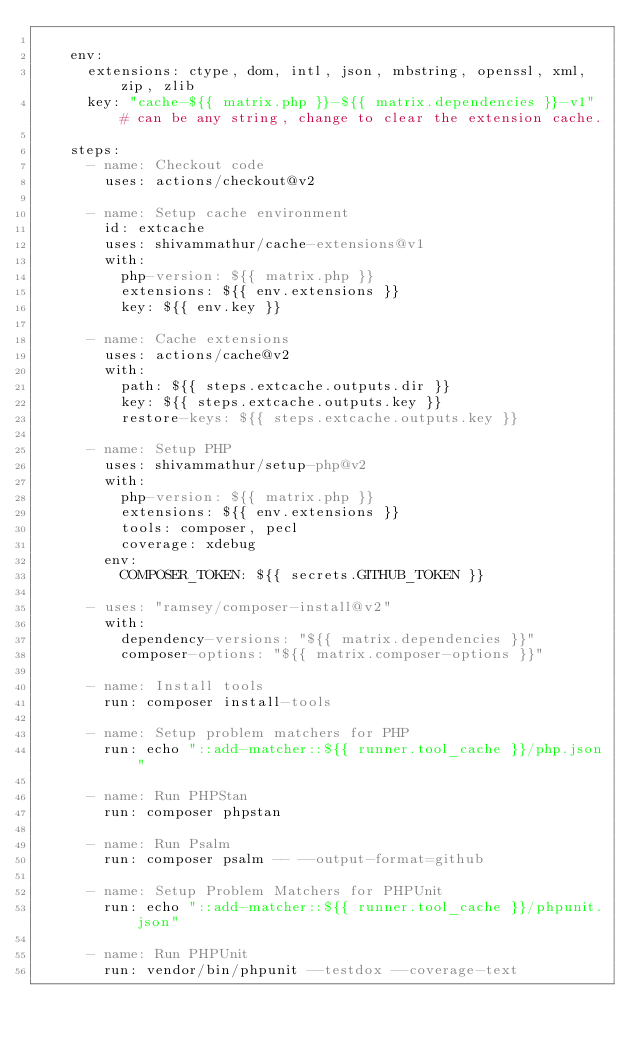Convert code to text. <code><loc_0><loc_0><loc_500><loc_500><_YAML_>
    env:
      extensions: ctype, dom, intl, json, mbstring, openssl, xml, zip, zlib
      key: "cache-${{ matrix.php }}-${{ matrix.dependencies }}-v1" # can be any string, change to clear the extension cache.

    steps:
      - name: Checkout code
        uses: actions/checkout@v2

      - name: Setup cache environment
        id: extcache
        uses: shivammathur/cache-extensions@v1
        with:
          php-version: ${{ matrix.php }}
          extensions: ${{ env.extensions }}
          key: ${{ env.key }}

      - name: Cache extensions
        uses: actions/cache@v2
        with:
          path: ${{ steps.extcache.outputs.dir }}
          key: ${{ steps.extcache.outputs.key }}
          restore-keys: ${{ steps.extcache.outputs.key }}

      - name: Setup PHP
        uses: shivammathur/setup-php@v2
        with:
          php-version: ${{ matrix.php }}
          extensions: ${{ env.extensions }}
          tools: composer, pecl
          coverage: xdebug
        env:
          COMPOSER_TOKEN: ${{ secrets.GITHUB_TOKEN }}

      - uses: "ramsey/composer-install@v2"
        with:
          dependency-versions: "${{ matrix.dependencies }}"
          composer-options: "${{ matrix.composer-options }}"

      - name: Install tools
        run: composer install-tools

      - name: Setup problem matchers for PHP
        run: echo "::add-matcher::${{ runner.tool_cache }}/php.json"

      - name: Run PHPStan
        run: composer phpstan

      - name: Run Psalm
        run: composer psalm -- --output-format=github

      - name: Setup Problem Matchers for PHPUnit
        run: echo "::add-matcher::${{ runner.tool_cache }}/phpunit.json"

      - name: Run PHPUnit
        run: vendor/bin/phpunit --testdox --coverage-text
</code> 